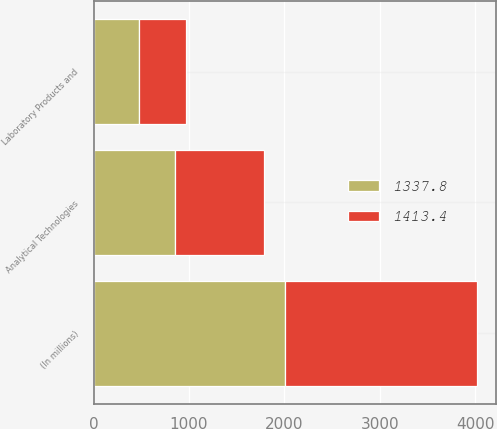Convert chart to OTSL. <chart><loc_0><loc_0><loc_500><loc_500><stacked_bar_chart><ecel><fcel>(In millions)<fcel>Analytical Technologies<fcel>Laboratory Products and<nl><fcel>1413.4<fcel>2010<fcel>925.2<fcel>488.2<nl><fcel>1337.8<fcel>2009<fcel>857<fcel>480.8<nl></chart> 